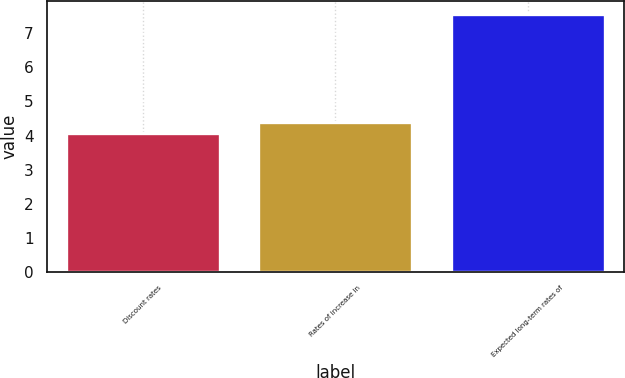Convert chart. <chart><loc_0><loc_0><loc_500><loc_500><bar_chart><fcel>Discount rates<fcel>Rates of increase in<fcel>Expected long-term rates of<nl><fcel>4.06<fcel>4.41<fcel>7.58<nl></chart> 